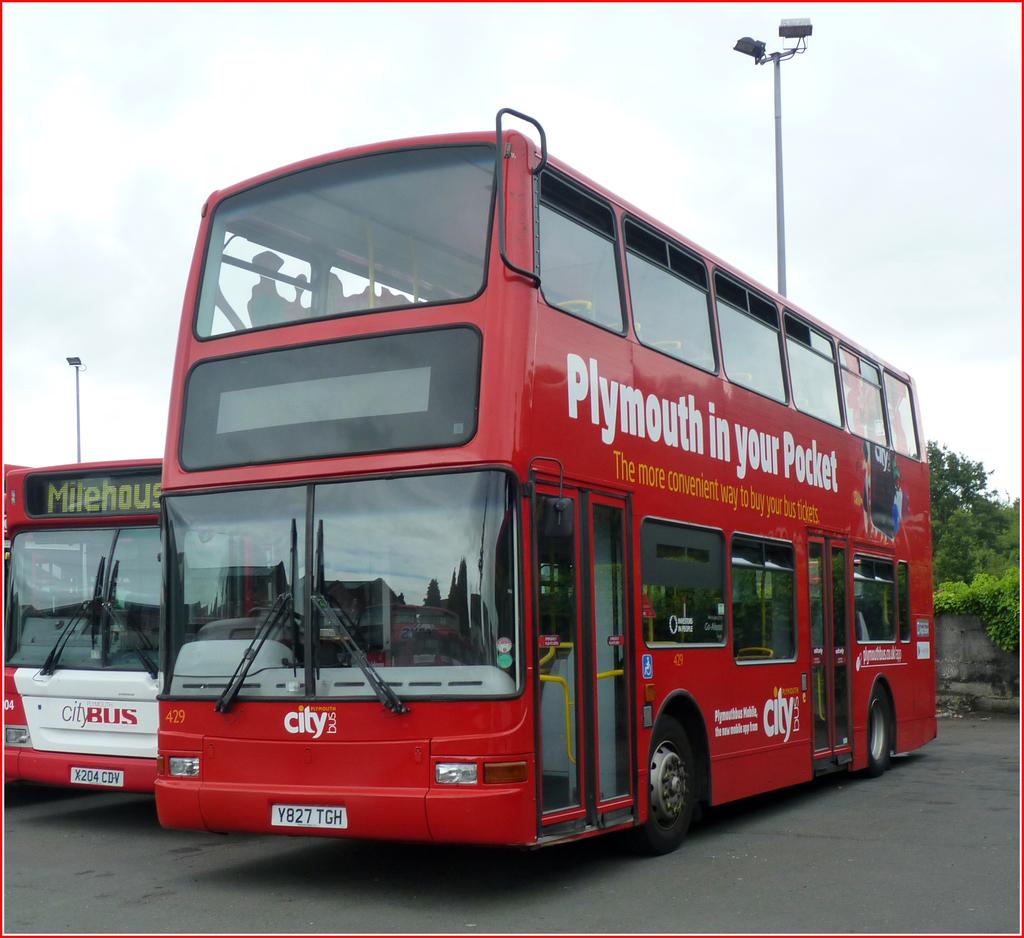Which city is "in your pocket?"?
Ensure brevity in your answer.  Plymouth. 